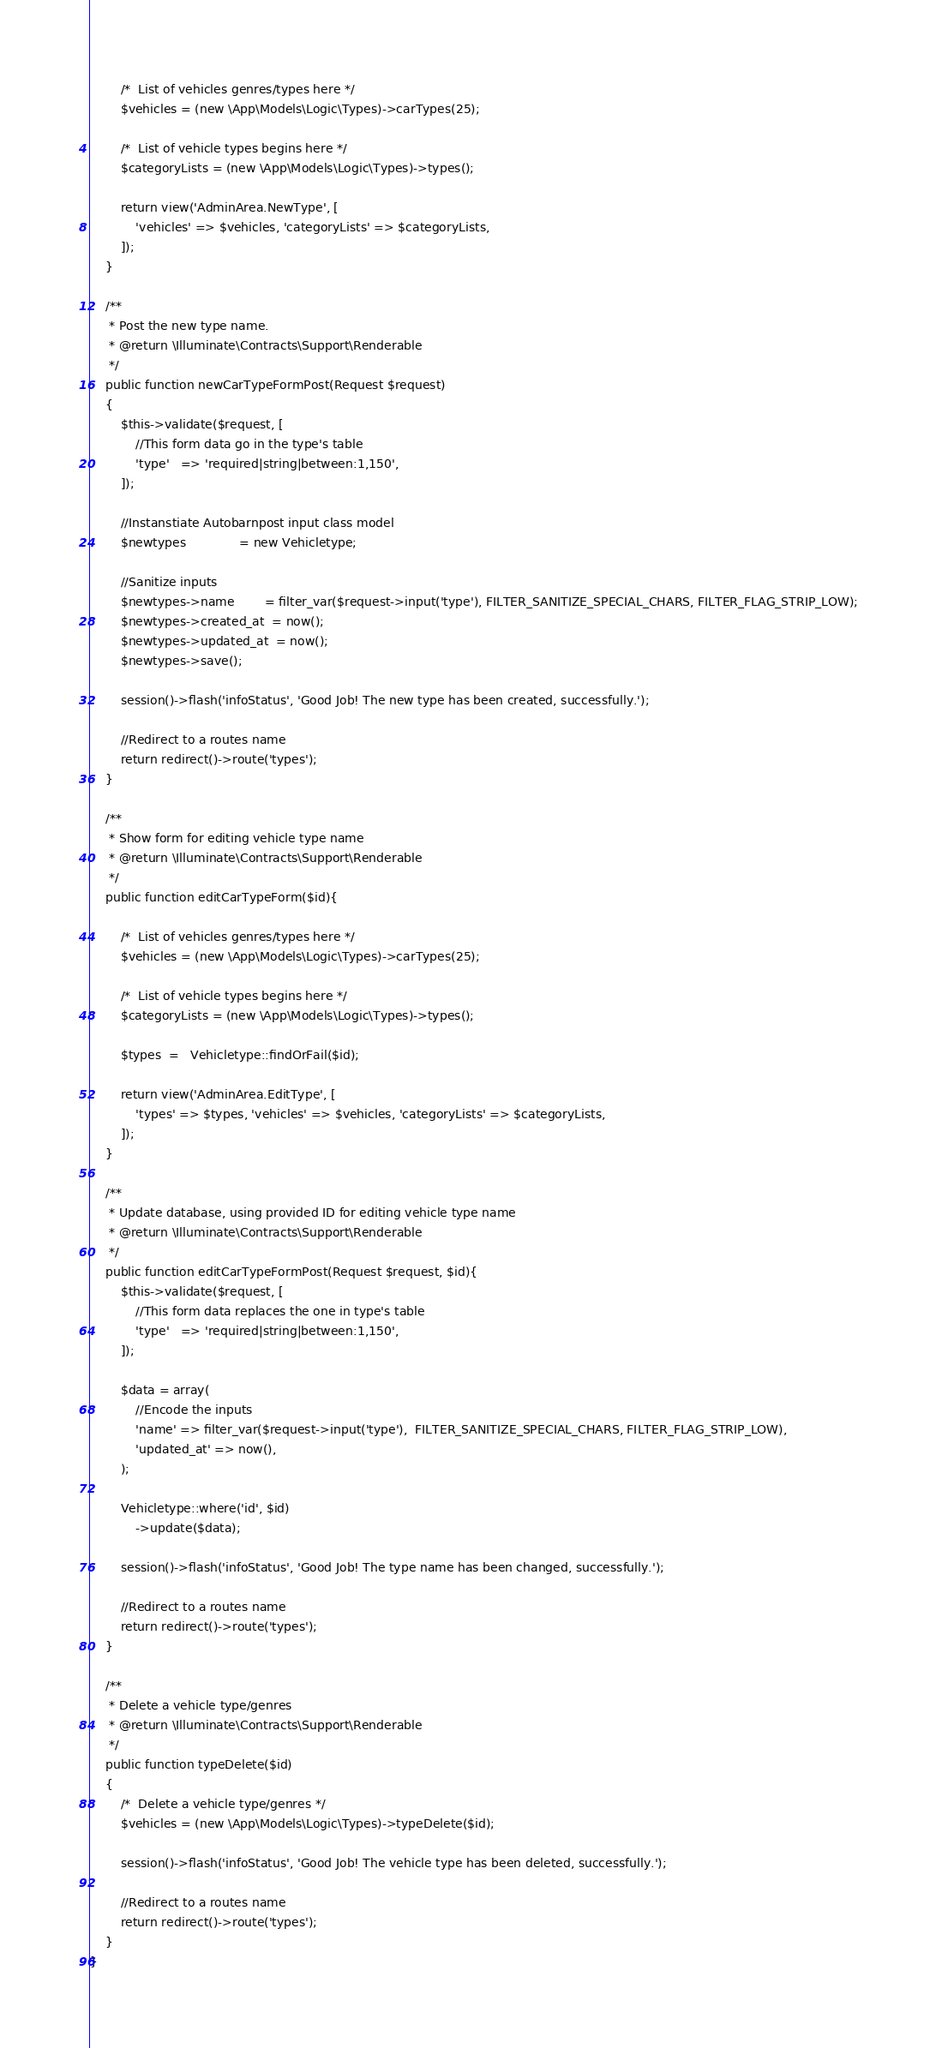Convert code to text. <code><loc_0><loc_0><loc_500><loc_500><_PHP_>        /*  List of vehicles genres/types here */
        $vehicles = (new \App\Models\Logic\Types)->carTypes(25);

        /*  List of vehicle types begins here */
        $categoryLists = (new \App\Models\Logic\Types)->types();

        return view('AdminArea.NewType', [
            'vehicles' => $vehicles, 'categoryLists' => $categoryLists,
        ]);
    }

    /**
     * Post the new type name.
     * @return \Illuminate\Contracts\Support\Renderable
     */
    public function newCarTypeFormPost(Request $request)
    {
        $this->validate($request, [
            //This form data go in the type's table
            'type'   => 'required|string|between:1,150',
        ]);

        //Instanstiate Autobarnpost input class model
        $newtypes              = new Vehicletype;

        //Sanitize inputs
        $newtypes->name        = filter_var($request->input('type'), FILTER_SANITIZE_SPECIAL_CHARS, FILTER_FLAG_STRIP_LOW);
        $newtypes->created_at  = now();
        $newtypes->updated_at  = now();
        $newtypes->save();

        session()->flash('infoStatus', 'Good Job! The new type has been created, successfully.');
        
        //Redirect to a routes name
        return redirect()->route('types');
    }

    /**
     * Show form for editing vehicle type name
     * @return \Illuminate\Contracts\Support\Renderable
     */ 
    public function editCarTypeForm($id){

        /*  List of vehicles genres/types here */
        $vehicles = (new \App\Models\Logic\Types)->carTypes(25);

        /*  List of vehicle types begins here */
        $categoryLists = (new \App\Models\Logic\Types)->types();
        
        $types  =   Vehicletype::findOrFail($id);

        return view('AdminArea.EditType', [
            'types' => $types, 'vehicles' => $vehicles, 'categoryLists' => $categoryLists,
        ]);
    }

    /**
     * Update database, using provided ID for editing vehicle type name
     * @return \Illuminate\Contracts\Support\Renderable
     */
    public function editCarTypeFormPost(Request $request, $id){
        $this->validate($request, [
            //This form data replaces the one in type's table
            'type'   => 'required|string|between:1,150',
        ]);

        $data = array(
            //Encode the inputs
            'name' => filter_var($request->input('type'),  FILTER_SANITIZE_SPECIAL_CHARS, FILTER_FLAG_STRIP_LOW),
            'updated_at' => now(),
        );

        Vehicletype::where('id', $id)
            ->update($data);

        session()->flash('infoStatus', 'Good Job! The type name has been changed, successfully.');

        //Redirect to a routes name
        return redirect()->route('types');
    }

    /**
     * Delete a vehicle type/genres
     * @return \Illuminate\Contracts\Support\Renderable
     */
    public function typeDelete($id)
    {
        /*  Delete a vehicle type/genres */
        $vehicles = (new \App\Models\Logic\Types)->typeDelete($id);

        session()->flash('infoStatus', 'Good Job! The vehicle type has been deleted, successfully.');
        
        //Redirect to a routes name
        return redirect()->route('types');
    }
}
</code> 